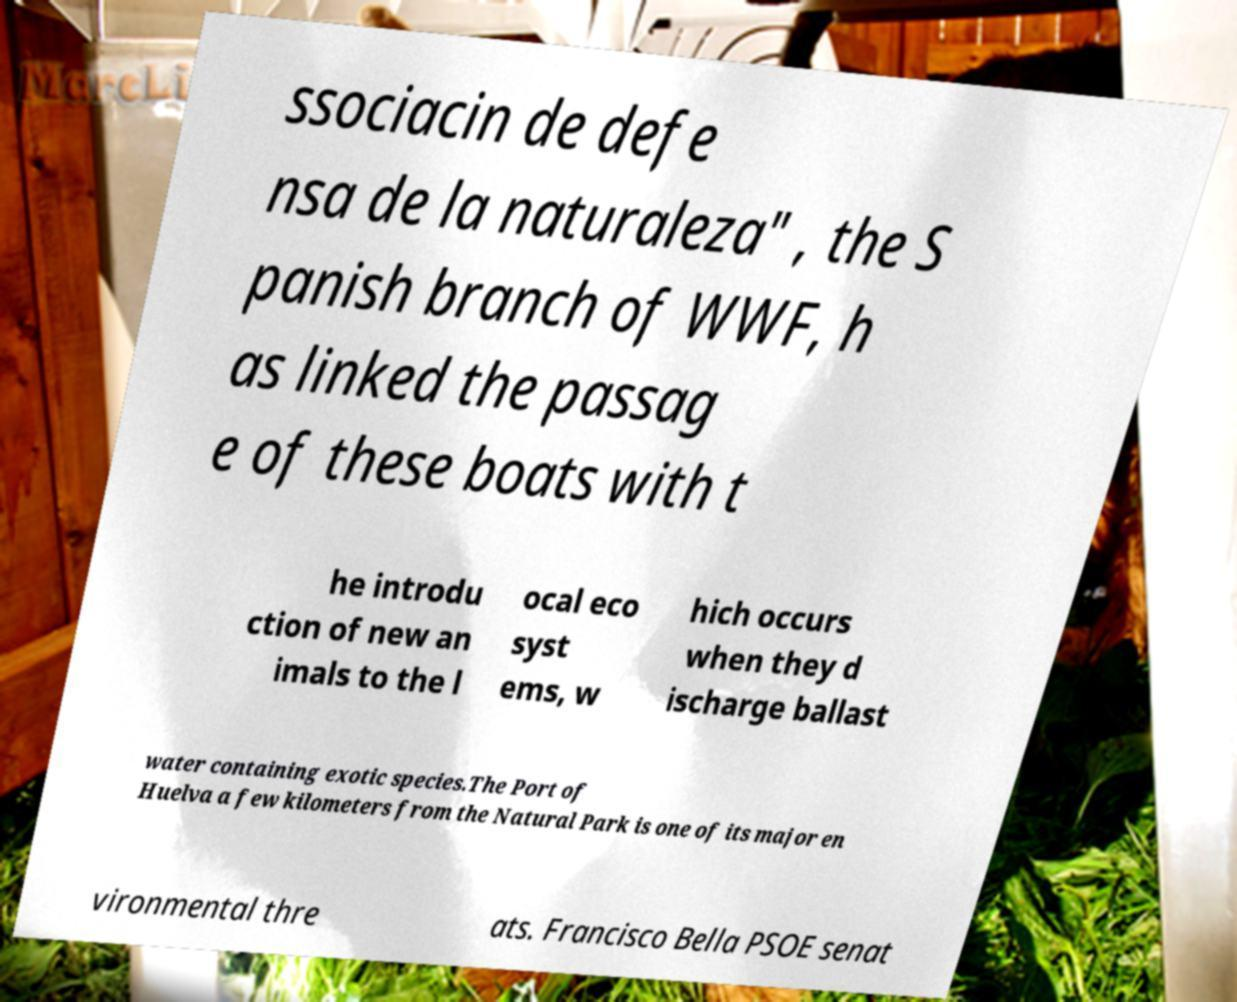Can you read and provide the text displayed in the image?This photo seems to have some interesting text. Can you extract and type it out for me? ssociacin de defe nsa de la naturaleza" , the S panish branch of WWF, h as linked the passag e of these boats with t he introdu ction of new an imals to the l ocal eco syst ems, w hich occurs when they d ischarge ballast water containing exotic species.The Port of Huelva a few kilometers from the Natural Park is one of its major en vironmental thre ats. Francisco Bella PSOE senat 